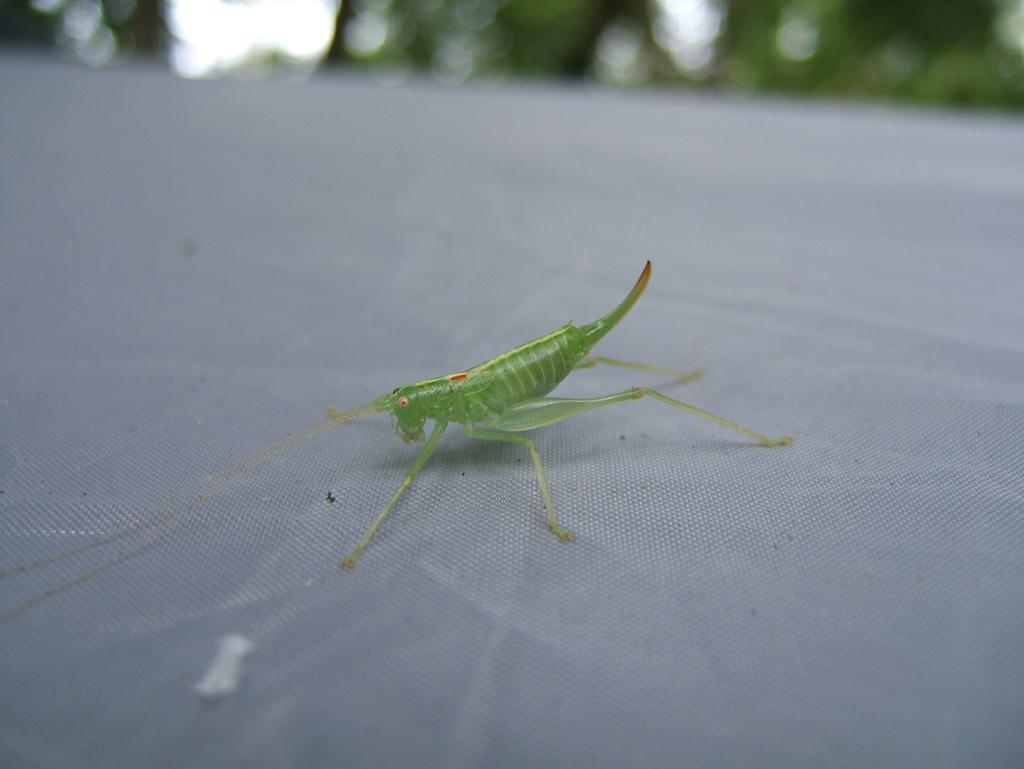What is the main subject of the image? The main subject of the image is a grasshopper. Where is the grasshopper located in the image? The grasshopper is on an object. Can you describe the background of the image? The background of the image is blurred. What type of desk is visible in the image? There is no desk present in the image; it features a grasshopper on an object with a blurred background. 